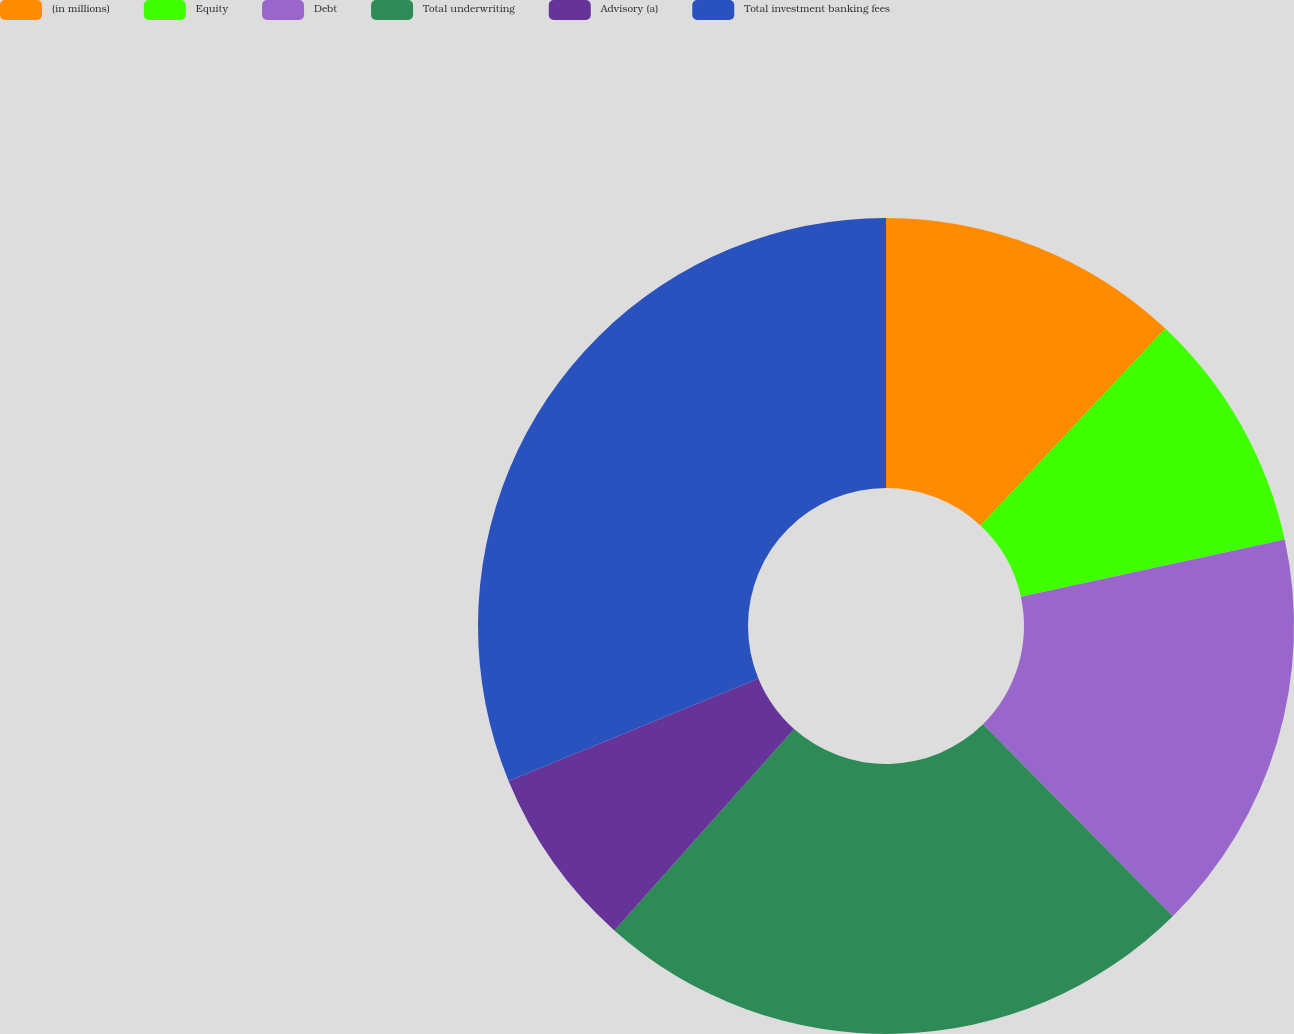Convert chart. <chart><loc_0><loc_0><loc_500><loc_500><pie_chart><fcel>(in millions)<fcel>Equity<fcel>Debt<fcel>Total underwriting<fcel>Advisory (a)<fcel>Total investment banking fees<nl><fcel>12.0%<fcel>9.6%<fcel>15.99%<fcel>24.0%<fcel>7.2%<fcel>31.2%<nl></chart> 